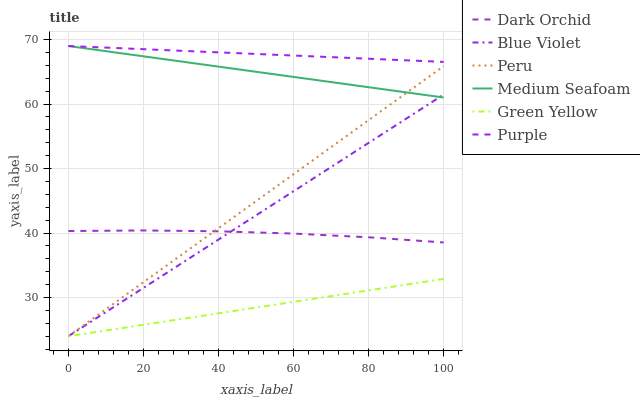Does Dark Orchid have the minimum area under the curve?
Answer yes or no. No. Does Dark Orchid have the maximum area under the curve?
Answer yes or no. No. Is Peru the smoothest?
Answer yes or no. No. Is Peru the roughest?
Answer yes or no. No. Does Dark Orchid have the lowest value?
Answer yes or no. No. Does Dark Orchid have the highest value?
Answer yes or no. No. Is Green Yellow less than Medium Seafoam?
Answer yes or no. Yes. Is Medium Seafoam greater than Dark Orchid?
Answer yes or no. Yes. Does Green Yellow intersect Medium Seafoam?
Answer yes or no. No. 